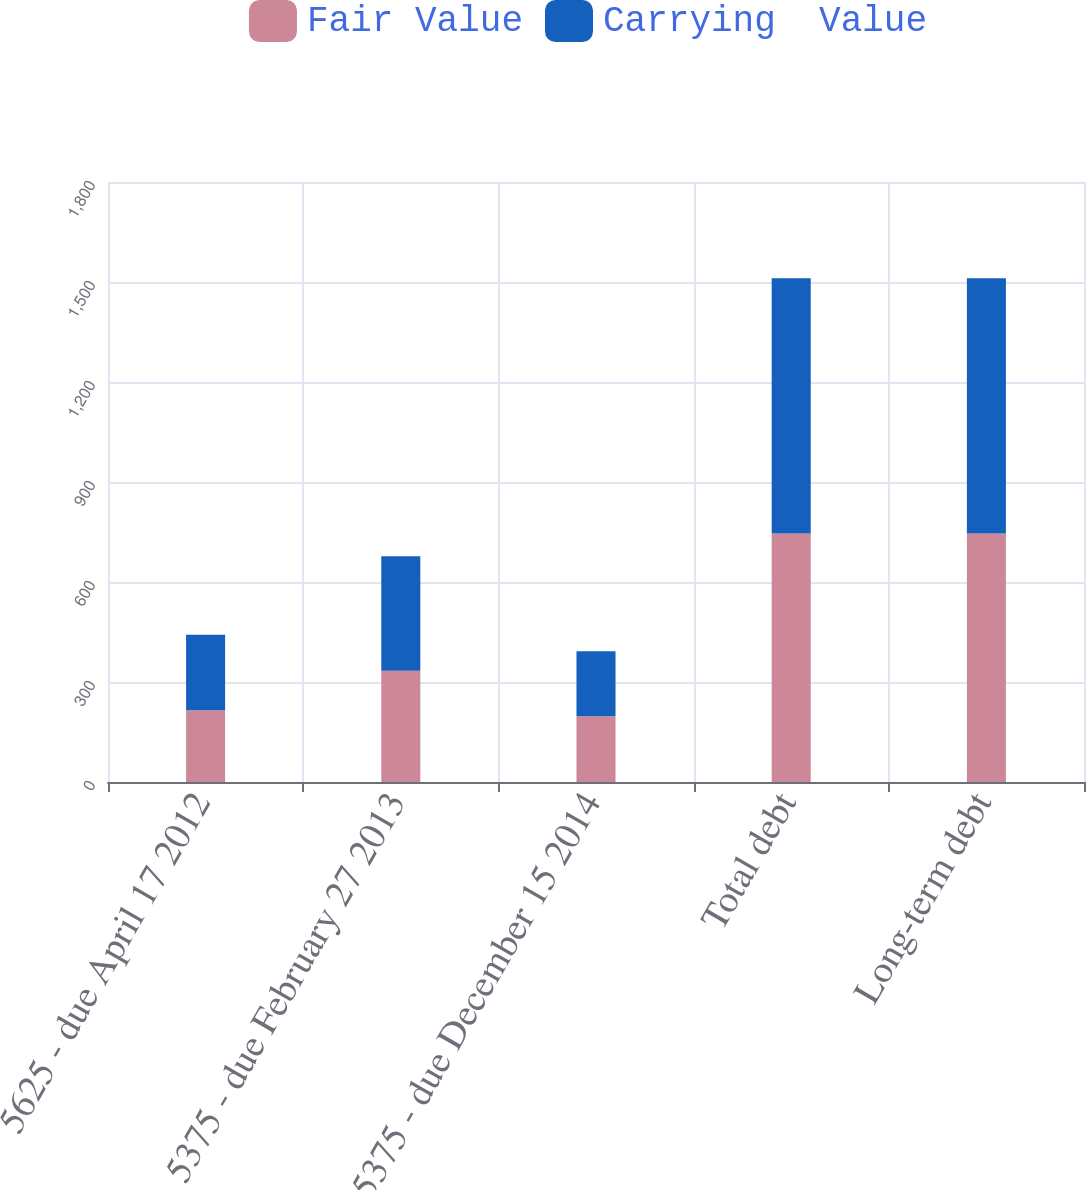<chart> <loc_0><loc_0><loc_500><loc_500><stacked_bar_chart><ecel><fcel>5625 - due April 17 2012<fcel>5375 - due February 27 2013<fcel>5375 - due December 15 2014<fcel>Total debt<fcel>Long-term debt<nl><fcel>Fair Value<fcel>215.1<fcel>333.5<fcel>197.1<fcel>745.7<fcel>745.7<nl><fcel>Carrying  Value<fcel>227<fcel>343.4<fcel>195.1<fcel>765.5<fcel>765.5<nl></chart> 